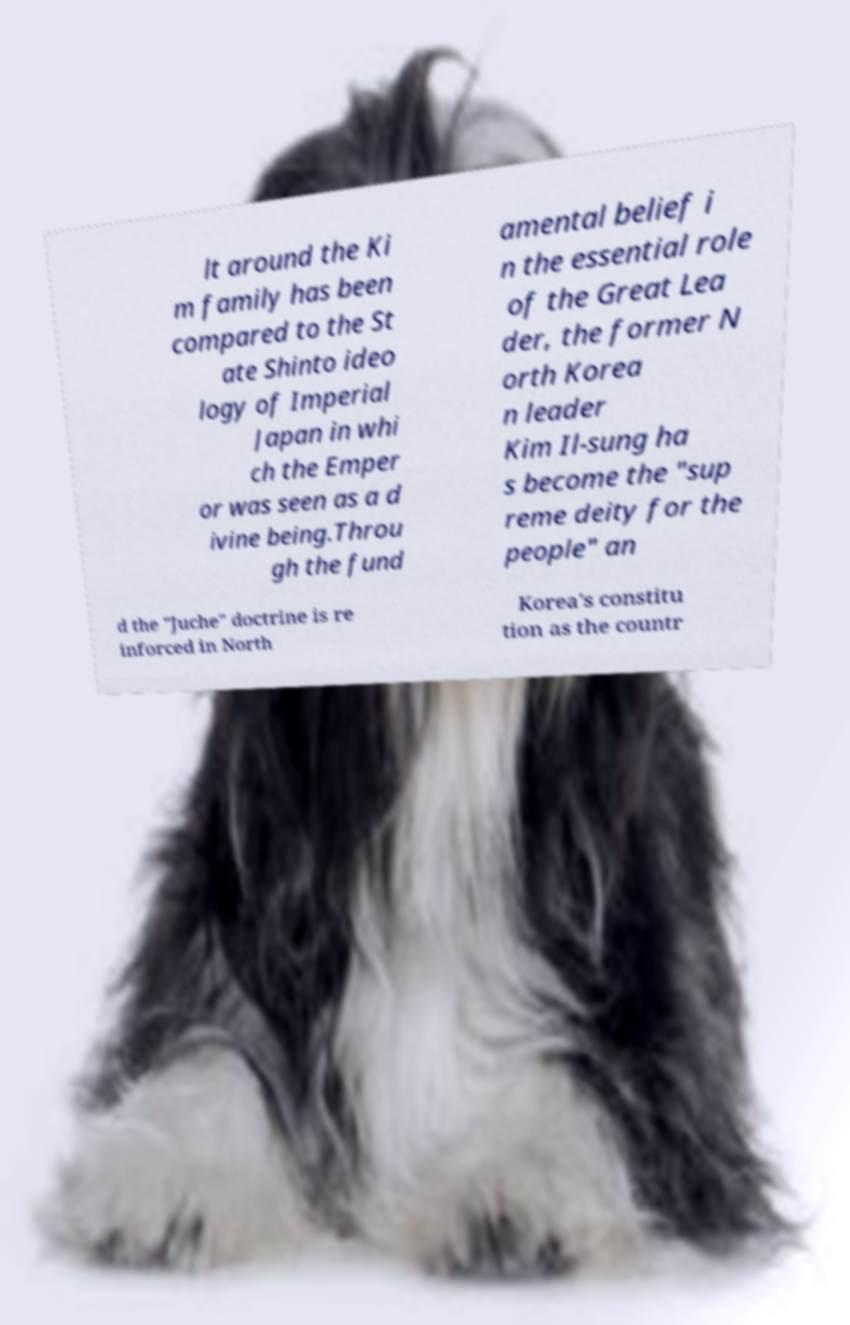Could you assist in decoding the text presented in this image and type it out clearly? lt around the Ki m family has been compared to the St ate Shinto ideo logy of Imperial Japan in whi ch the Emper or was seen as a d ivine being.Throu gh the fund amental belief i n the essential role of the Great Lea der, the former N orth Korea n leader Kim Il-sung ha s become the "sup reme deity for the people" an d the "Juche" doctrine is re inforced in North Korea's constitu tion as the countr 